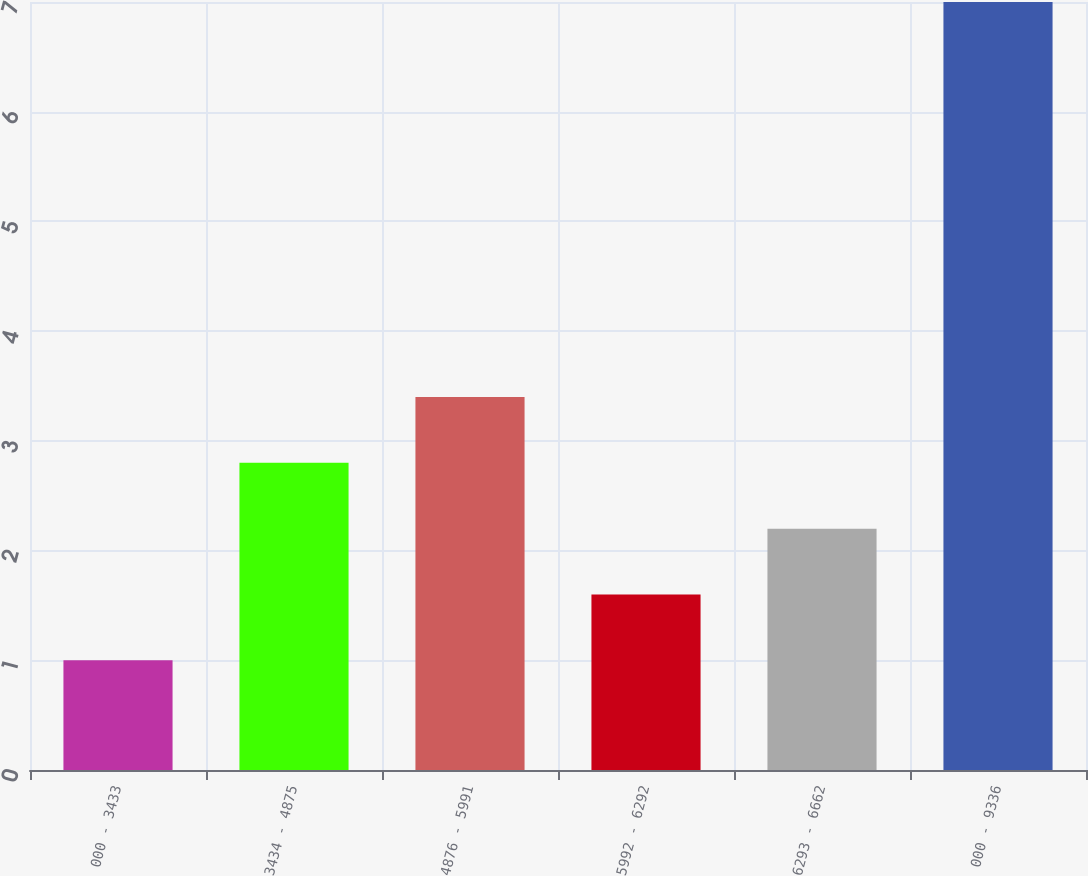<chart> <loc_0><loc_0><loc_500><loc_500><bar_chart><fcel>000 - 3433<fcel>3434 - 4875<fcel>4876 - 5991<fcel>5992 - 6292<fcel>6293 - 6662<fcel>000 - 9336<nl><fcel>1<fcel>2.8<fcel>3.4<fcel>1.6<fcel>2.2<fcel>7<nl></chart> 